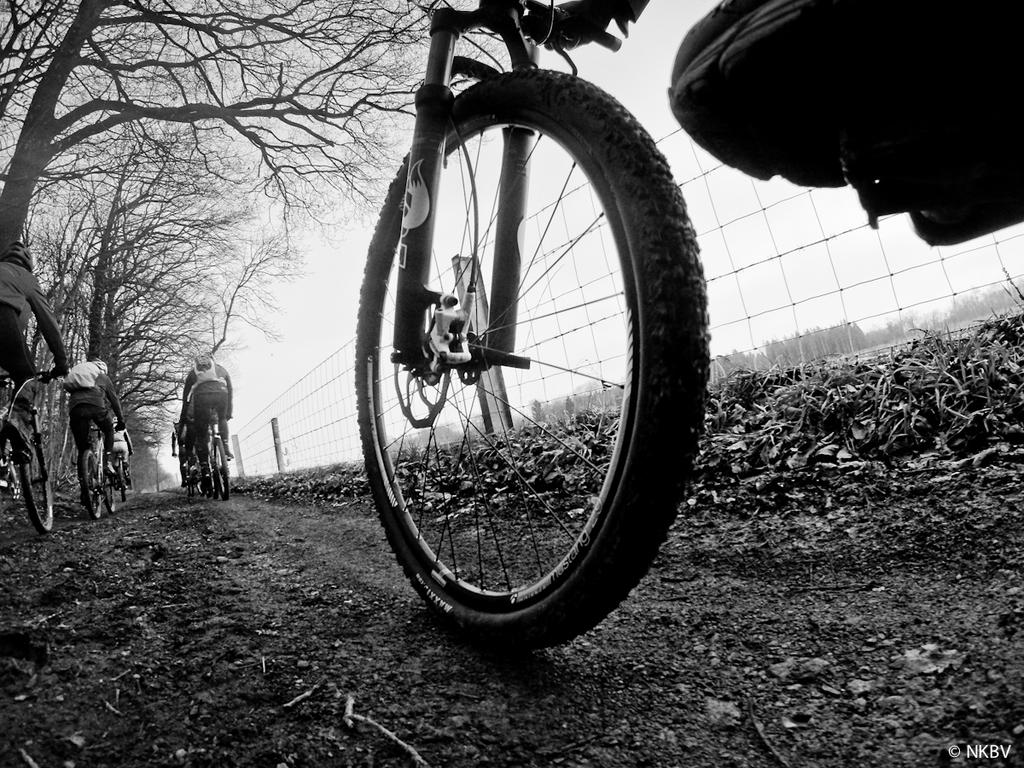What are the persons in the image doing? The persons in the image are riding bicycles. What can be seen in the image besides the persons riding bicycles? There is a mesh, dried leaves, trees, and the sky visible in the image. What type of vegetation is present in the image? Trees are present in the image. What is visible in the background of the image? The sky is visible in the background of the image. What type of notebook is being used to write jokes while riding the bicycle in the image? There is no notebook or humor-related activity present in the image; the persons are simply riding bicycles. What color is the shirt of the person riding the bicycle in the image? The provided facts do not mention the color of any person's shirt in the image. 